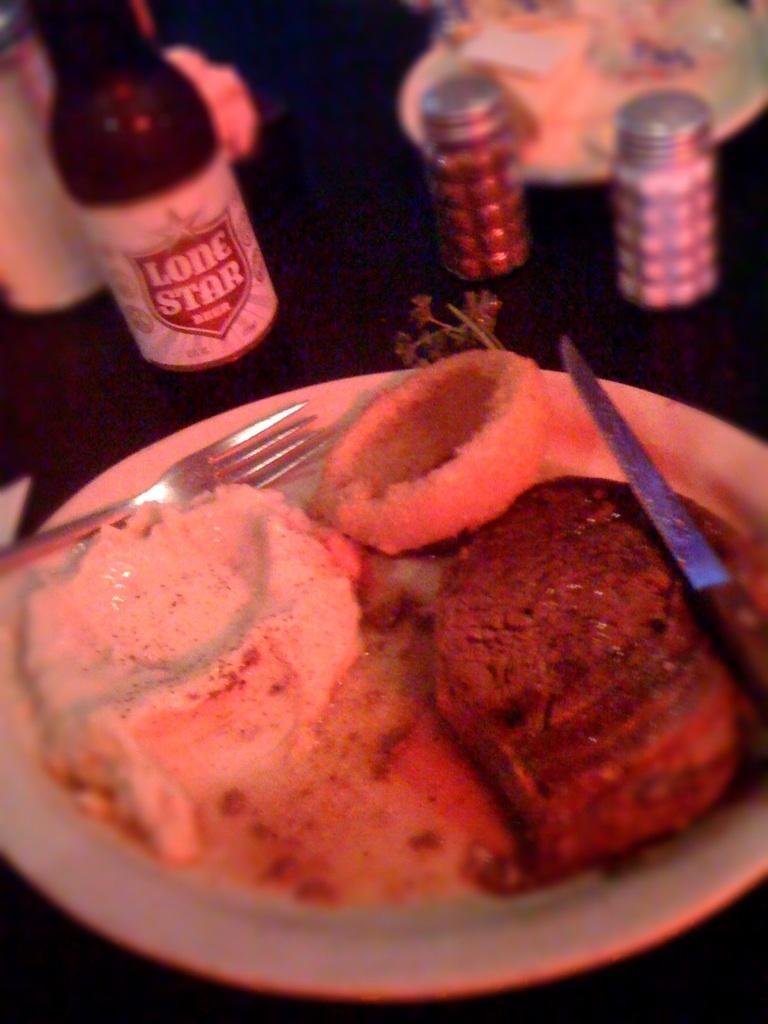Can you describe this image briefly? In the left bottom, there is a plate on which knife, fork and food is kept. In the top, wine bottle and jar are there which are kept on the table. This image is taken in a dining room. 